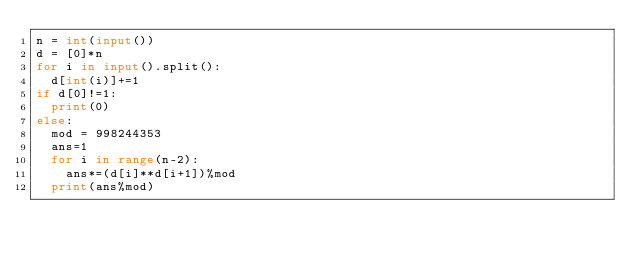<code> <loc_0><loc_0><loc_500><loc_500><_Python_>n = int(input())
d = [0]*n
for i in input().split():
  d[int(i)]+=1
if d[0]!=1:
  print(0)
else:
  mod = 998244353
  ans=1
  for i in range(n-2):
    ans*=(d[i]**d[i+1])%mod
  print(ans%mod)</code> 